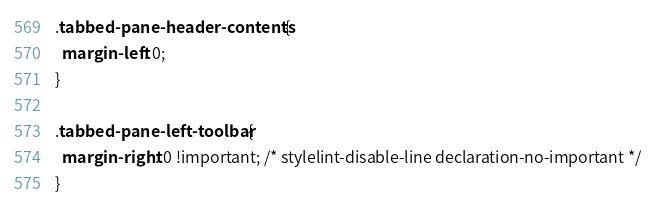Convert code to text. <code><loc_0><loc_0><loc_500><loc_500><_CSS_>.tabbed-pane-header-contents {
  margin-left: 0;
}

.tabbed-pane-left-toolbar {
  margin-right: 0 !important; /* stylelint-disable-line declaration-no-important */
}
</code> 